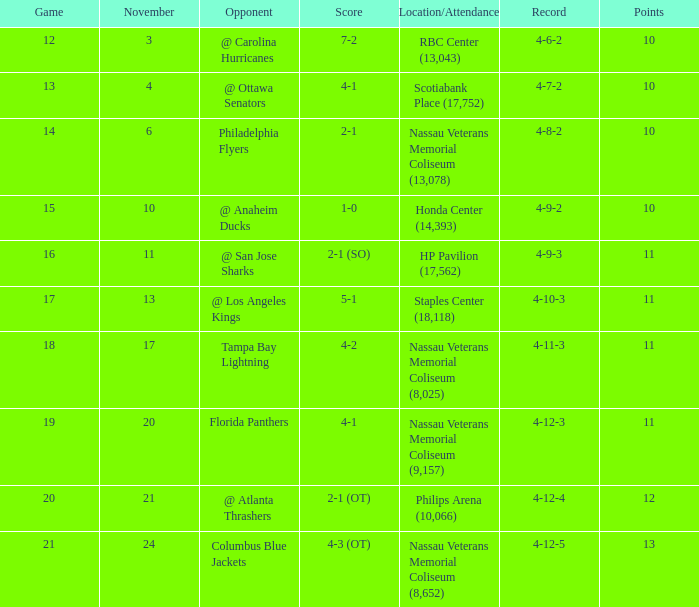What is the minimum requirement to enter the game with a score of 1-0? 15.0. 